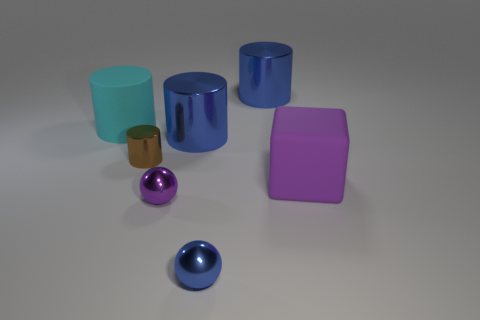Are there any cyan objects in front of the small blue shiny sphere?
Your answer should be very brief. No. What color is the other rubber thing that is the same shape as the brown thing?
Your response must be concise. Cyan. Is there anything else that is the same shape as the big purple thing?
Your answer should be compact. No. What is the material of the large cylinder that is to the right of the small blue sphere?
Ensure brevity in your answer.  Metal. There is a cyan rubber object that is the same shape as the tiny brown metallic thing; what size is it?
Your answer should be very brief. Large. What number of other cyan cylinders are made of the same material as the large cyan cylinder?
Make the answer very short. 0. What number of tiny balls are the same color as the big cube?
Your answer should be very brief. 1. What number of things are either blue metallic cylinders on the right side of the small blue metal object or rubber things on the left side of the big purple rubber cube?
Offer a terse response. 2. Are there fewer tiny metal spheres that are behind the cube than large green cylinders?
Provide a short and direct response. No. Is there a sphere that has the same size as the cyan cylinder?
Your answer should be very brief. No. 